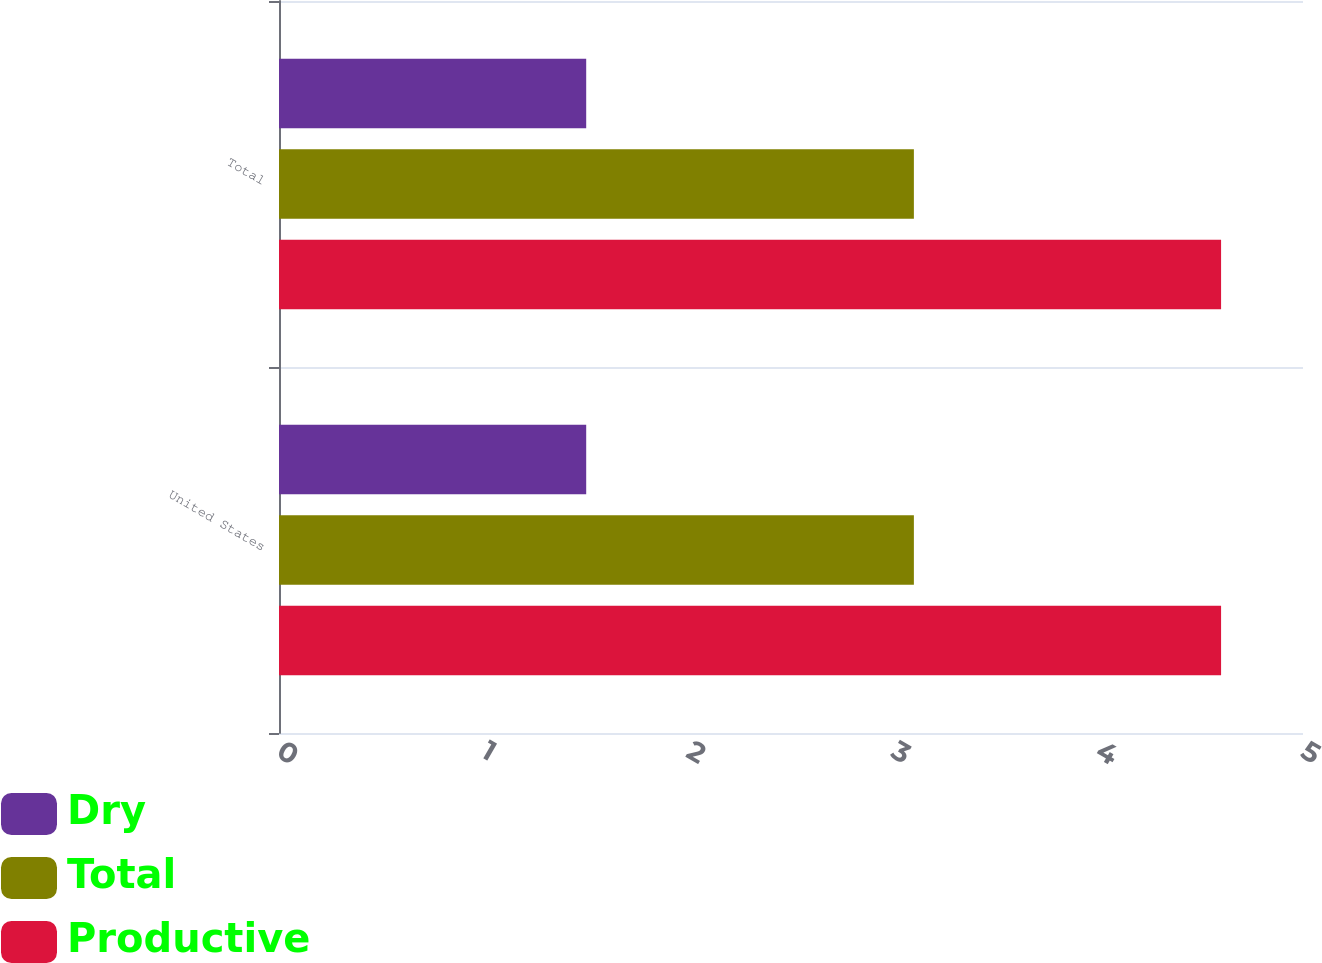Convert chart. <chart><loc_0><loc_0><loc_500><loc_500><stacked_bar_chart><ecel><fcel>United States<fcel>Total<nl><fcel>Dry<fcel>1.5<fcel>1.5<nl><fcel>Total<fcel>3.1<fcel>3.1<nl><fcel>Productive<fcel>4.6<fcel>4.6<nl></chart> 